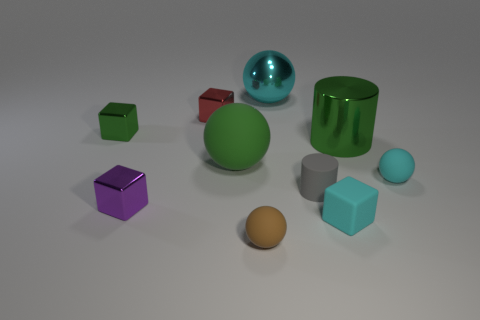What number of spheres are yellow metallic objects or small purple things?
Your response must be concise. 0. There is a big object that is behind the big green cylinder; is there a big metallic object that is in front of it?
Keep it short and to the point. Yes. Is the number of big things less than the number of small purple blocks?
Offer a terse response. No. How many big green matte objects have the same shape as the cyan metallic object?
Offer a terse response. 1. What number of green objects are either big cylinders or large rubber things?
Offer a terse response. 2. What is the size of the matte ball in front of the shiny block that is in front of the big green ball?
Your answer should be very brief. Small. What is the material of the green thing that is the same shape as the small purple object?
Your answer should be compact. Metal. What number of red metallic objects are the same size as the gray thing?
Offer a terse response. 1. Do the purple shiny cube and the cyan rubber block have the same size?
Your response must be concise. Yes. There is a matte sphere that is left of the tiny rubber cube and behind the small brown object; how big is it?
Your answer should be compact. Large. 